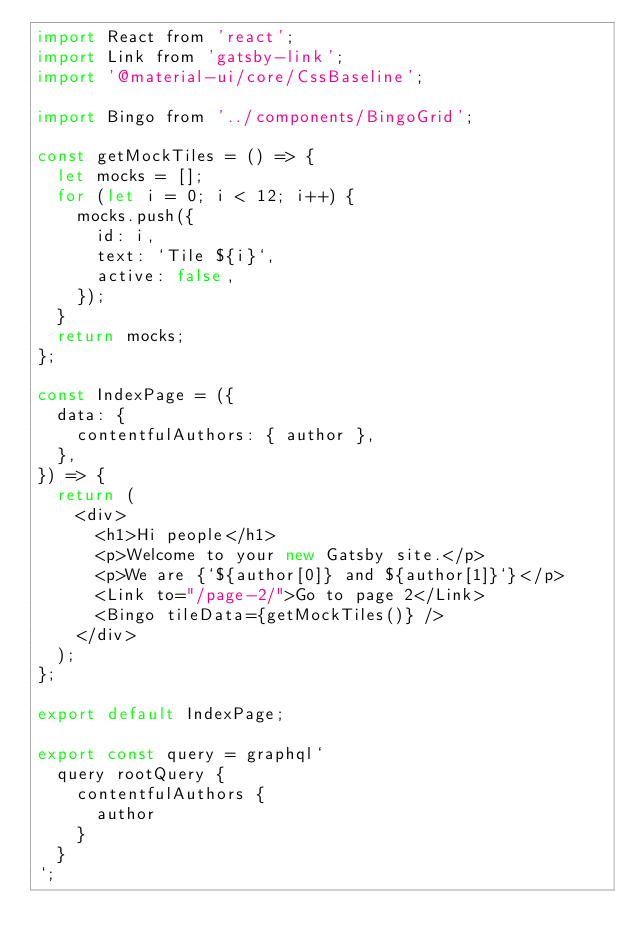Convert code to text. <code><loc_0><loc_0><loc_500><loc_500><_JavaScript_>import React from 'react';
import Link from 'gatsby-link';
import '@material-ui/core/CssBaseline';

import Bingo from '../components/BingoGrid';

const getMockTiles = () => {
  let mocks = [];
  for (let i = 0; i < 12; i++) {
    mocks.push({
      id: i,
      text: `Tile ${i}`,
      active: false,
    });
  }
  return mocks;
};

const IndexPage = ({
  data: {
    contentfulAuthors: { author },
  },
}) => {
  return (
    <div>
      <h1>Hi people</h1>
      <p>Welcome to your new Gatsby site.</p>
      <p>We are {`${author[0]} and ${author[1]}`}</p>
      <Link to="/page-2/">Go to page 2</Link>
      <Bingo tileData={getMockTiles()} />
    </div>
  );
};

export default IndexPage;

export const query = graphql`
  query rootQuery {
    contentfulAuthors {
      author
    }
  }
`;
</code> 